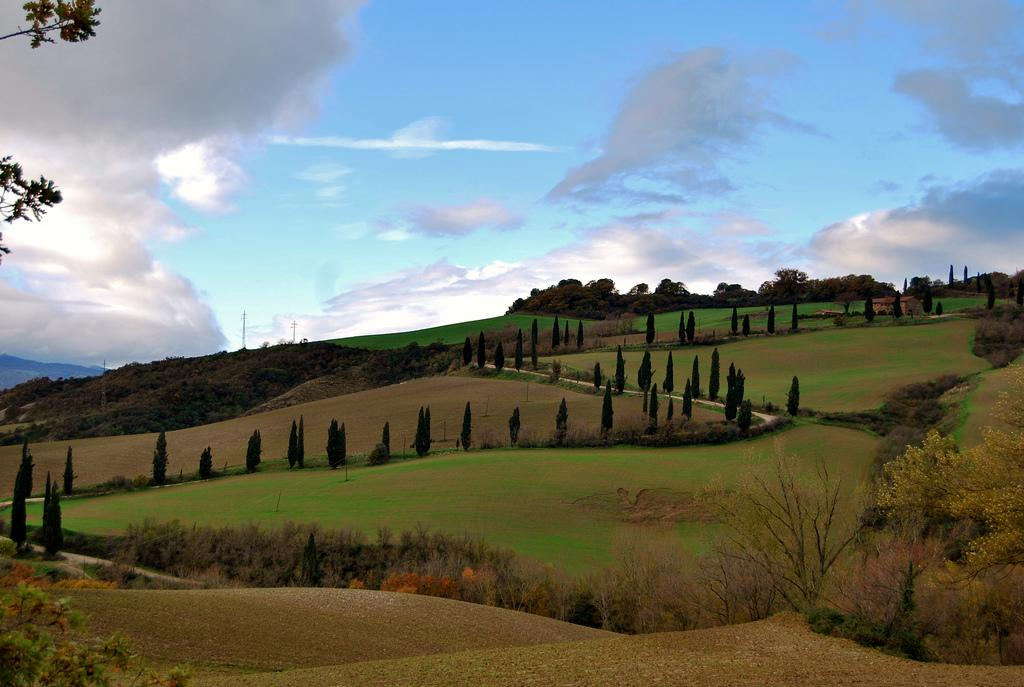What type of vegetation can be seen in the image? There are trees and bushes in the image. Where are the trees and bushes located in the image? The trees and bushes are at the center of the image. What is visible at the top of the image? The sky is visible at the top of the image. What type of account is being written about the trees and bushes in the image? There is no account being written about the trees and bushes in the image. Can you see any pets interacting with the trees and bushes in the image? There are no pets present in the image. 